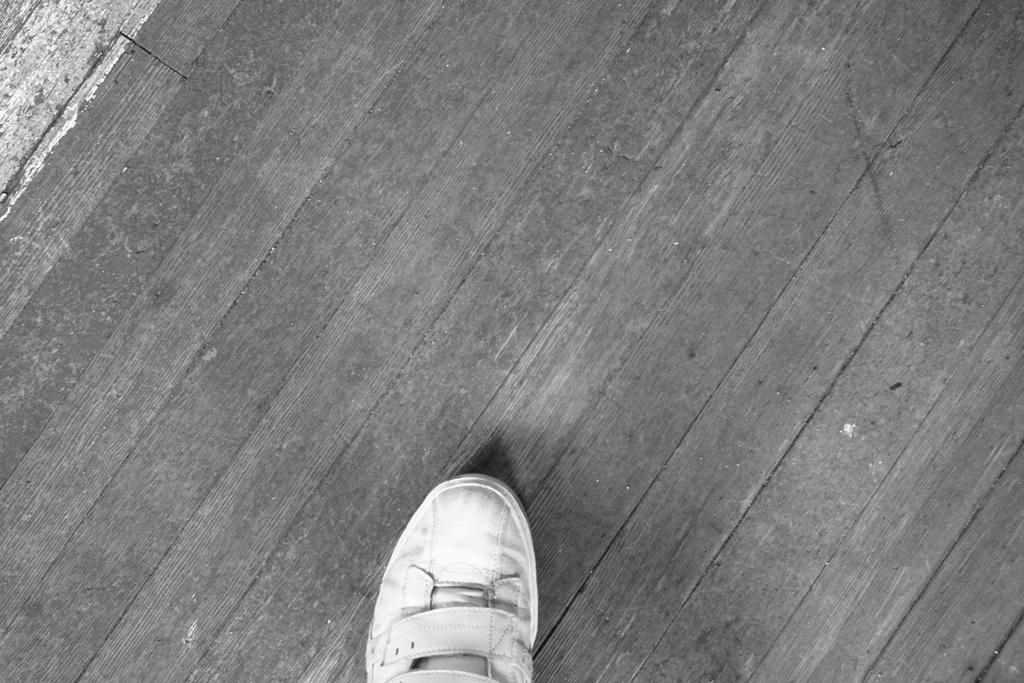What is the color scheme of the image? The image is black and white. What object can be seen in the image? There is a shoe in the image. What type of surface is the shoe placed on? The shoe is on a wooden surface. What type of chalk is being used to draw on the shoe in the image? There is no chalk or drawing on the shoe in the image; it is a simple black and white image of a shoe on a wooden surface. 